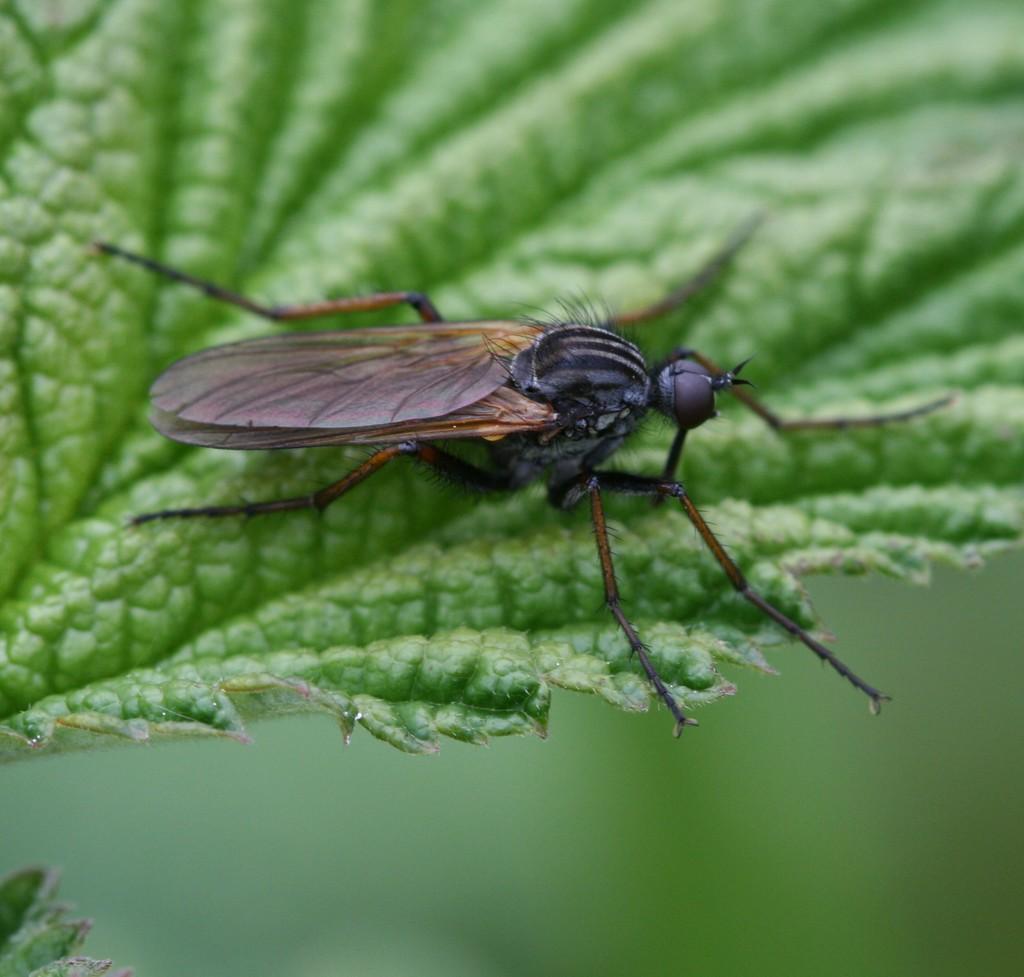In one or two sentences, can you explain what this image depicts? In this picture I can see the insect on the leaf. 